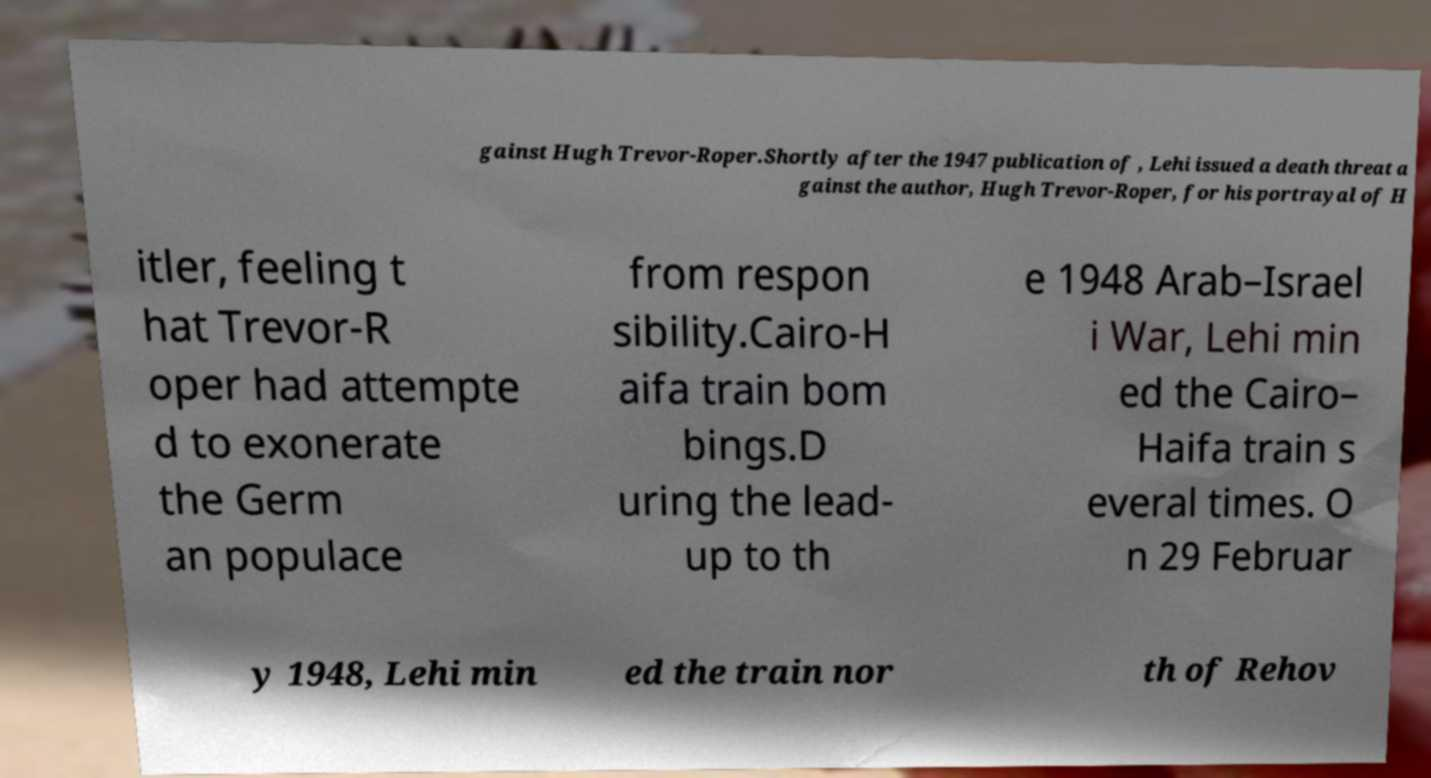Could you extract and type out the text from this image? gainst Hugh Trevor-Roper.Shortly after the 1947 publication of , Lehi issued a death threat a gainst the author, Hugh Trevor-Roper, for his portrayal of H itler, feeling t hat Trevor-R oper had attempte d to exonerate the Germ an populace from respon sibility.Cairo-H aifa train bom bings.D uring the lead- up to th e 1948 Arab–Israel i War, Lehi min ed the Cairo– Haifa train s everal times. O n 29 Februar y 1948, Lehi min ed the train nor th of Rehov 